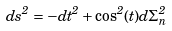Convert formula to latex. <formula><loc_0><loc_0><loc_500><loc_500>d s ^ { 2 } = - d t ^ { 2 } + \cos ^ { 2 } ( t ) d \Sigma ^ { 2 } _ { n }</formula> 